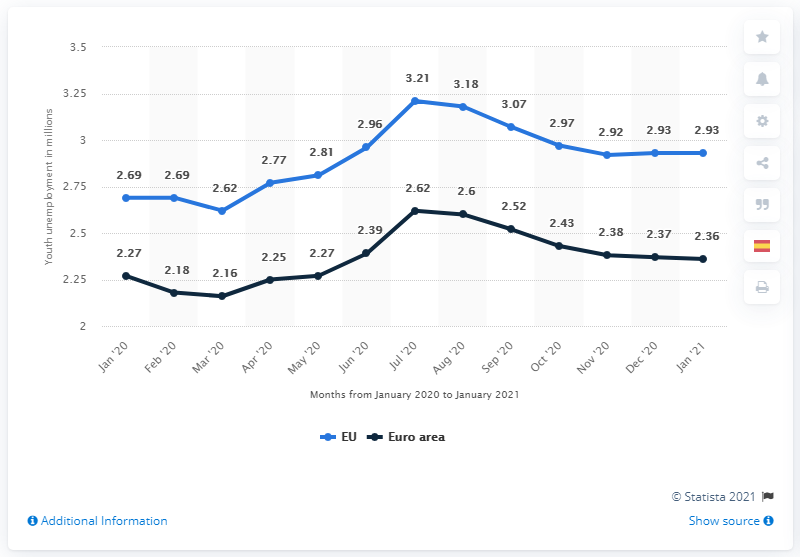Draw attention to some important aspects in this diagram. In January 2021, 2.93 million young people in the EU were unemployed. 